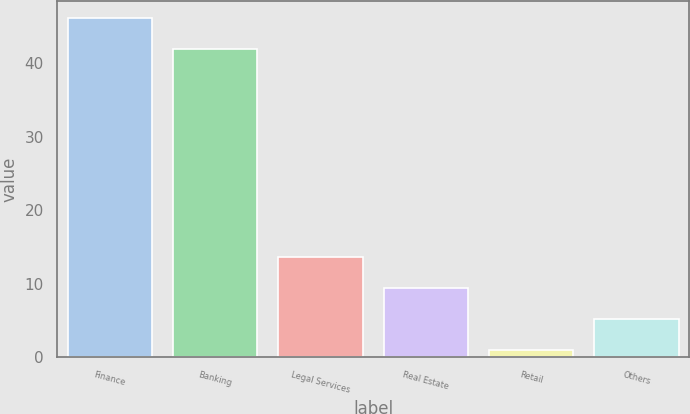Convert chart. <chart><loc_0><loc_0><loc_500><loc_500><bar_chart><fcel>Finance<fcel>Banking<fcel>Legal Services<fcel>Real Estate<fcel>Retail<fcel>Others<nl><fcel>46.2<fcel>42<fcel>13.6<fcel>9.4<fcel>1<fcel>5.2<nl></chart> 